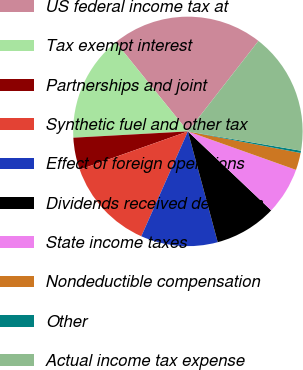<chart> <loc_0><loc_0><loc_500><loc_500><pie_chart><fcel>US federal income tax at<fcel>Tax exempt interest<fcel>Partnerships and joint<fcel>Synthetic fuel and other tax<fcel>Effect of foreign operations<fcel>Dividends received deduction<fcel>State income taxes<fcel>Nondeductible compensation<fcel>Other<fcel>Actual income tax expense<nl><fcel>21.36%<fcel>15.05%<fcel>4.53%<fcel>12.94%<fcel>10.84%<fcel>8.74%<fcel>6.63%<fcel>2.43%<fcel>0.32%<fcel>17.15%<nl></chart> 